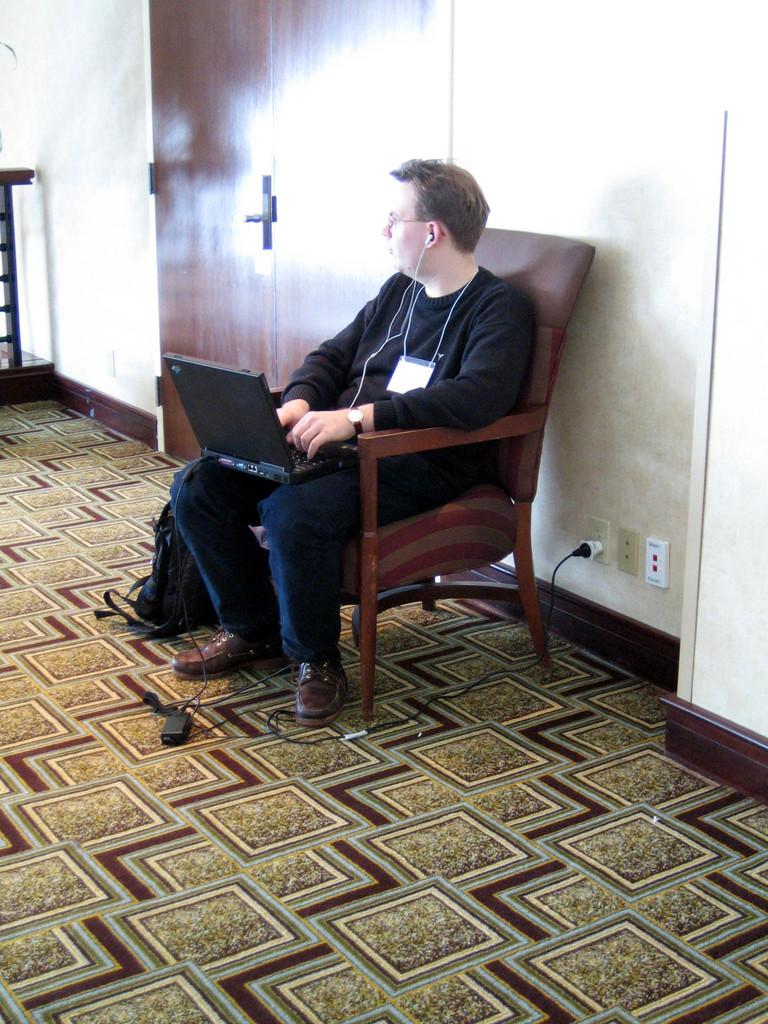What is the person in the image doing? The person is sitting on a chair in the image. What object is the person holding or using? The person has a laptop on their lap. What can be seen in the background of the image? There is a door visible in the background of the image. What else is present in the image besides the person and the laptop? There are wires and a bag present in the image. What type of nerve can be seen in the image? There are no nerves visible in the image. Is there a knife present in the image? No, there is no knife present in the image. 